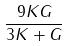<formula> <loc_0><loc_0><loc_500><loc_500>\frac { 9 K G } { 3 K + G }</formula> 